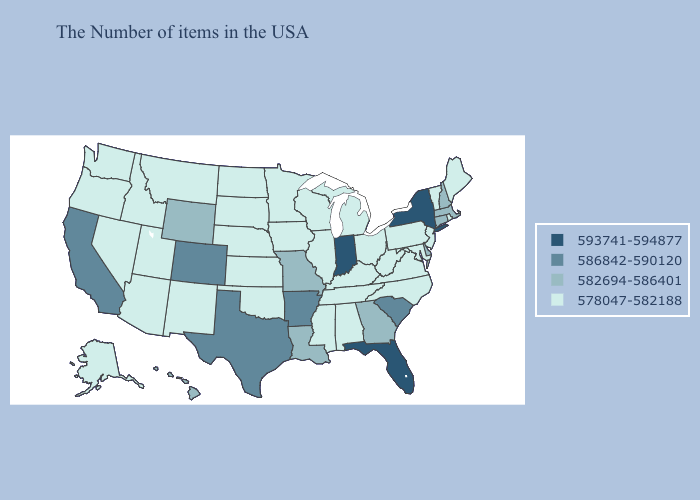Does Wyoming have the highest value in the West?
Answer briefly. No. Name the states that have a value in the range 586842-590120?
Concise answer only. South Carolina, Arkansas, Texas, Colorado, California. What is the highest value in the USA?
Keep it brief. 593741-594877. What is the value of New Hampshire?
Give a very brief answer. 582694-586401. Name the states that have a value in the range 593741-594877?
Concise answer only. New York, Florida, Indiana. What is the highest value in states that border Ohio?
Keep it brief. 593741-594877. What is the value of Washington?
Short answer required. 578047-582188. Does Florida have the highest value in the South?
Answer briefly. Yes. Name the states that have a value in the range 578047-582188?
Write a very short answer. Maine, Rhode Island, Vermont, New Jersey, Maryland, Pennsylvania, Virginia, North Carolina, West Virginia, Ohio, Michigan, Kentucky, Alabama, Tennessee, Wisconsin, Illinois, Mississippi, Minnesota, Iowa, Kansas, Nebraska, Oklahoma, South Dakota, North Dakota, New Mexico, Utah, Montana, Arizona, Idaho, Nevada, Washington, Oregon, Alaska. Does the map have missing data?
Short answer required. No. What is the value of Utah?
Answer briefly. 578047-582188. Name the states that have a value in the range 578047-582188?
Give a very brief answer. Maine, Rhode Island, Vermont, New Jersey, Maryland, Pennsylvania, Virginia, North Carolina, West Virginia, Ohio, Michigan, Kentucky, Alabama, Tennessee, Wisconsin, Illinois, Mississippi, Minnesota, Iowa, Kansas, Nebraska, Oklahoma, South Dakota, North Dakota, New Mexico, Utah, Montana, Arizona, Idaho, Nevada, Washington, Oregon, Alaska. What is the value of Arizona?
Concise answer only. 578047-582188. Is the legend a continuous bar?
Give a very brief answer. No. Name the states that have a value in the range 593741-594877?
Answer briefly. New York, Florida, Indiana. 